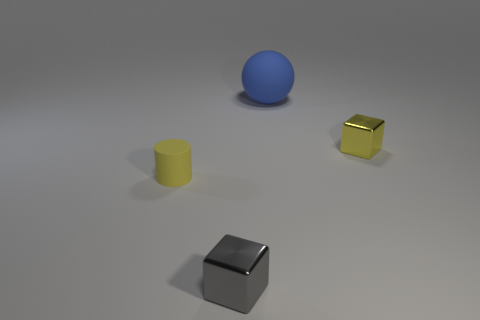The big object is what shape? sphere 